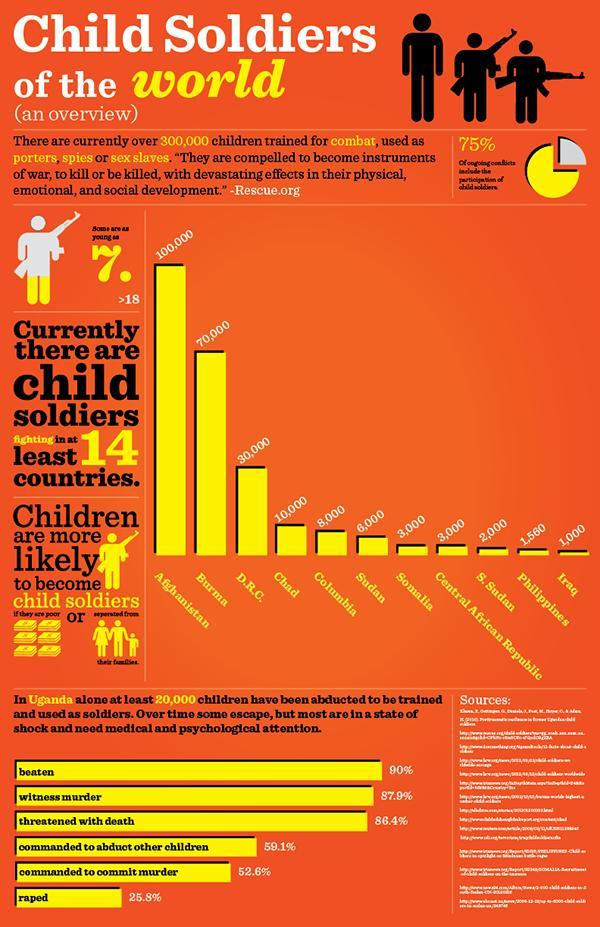Which is the third-most purpose of Child abduction?
Answer the question with a short phrase. threatened with death How many child soldiers are present in Sudan and Somalia took together? 9,000 How many countries have the no of child soldiers less than 3,000? 3 In which country seventh-highest no of child soldiers are present? Somalia Which is the second-most purpose of Child abduction? witness murder Which is the fifth-most purpose of Child abduction? commanded to commit murder In which country fifth-highest no of child soldiers are present? Columbia How many child soldiers are present in Iraq and the Philippines took together? 2,560 In which country second-highest no of child soldiers are present? Burma 